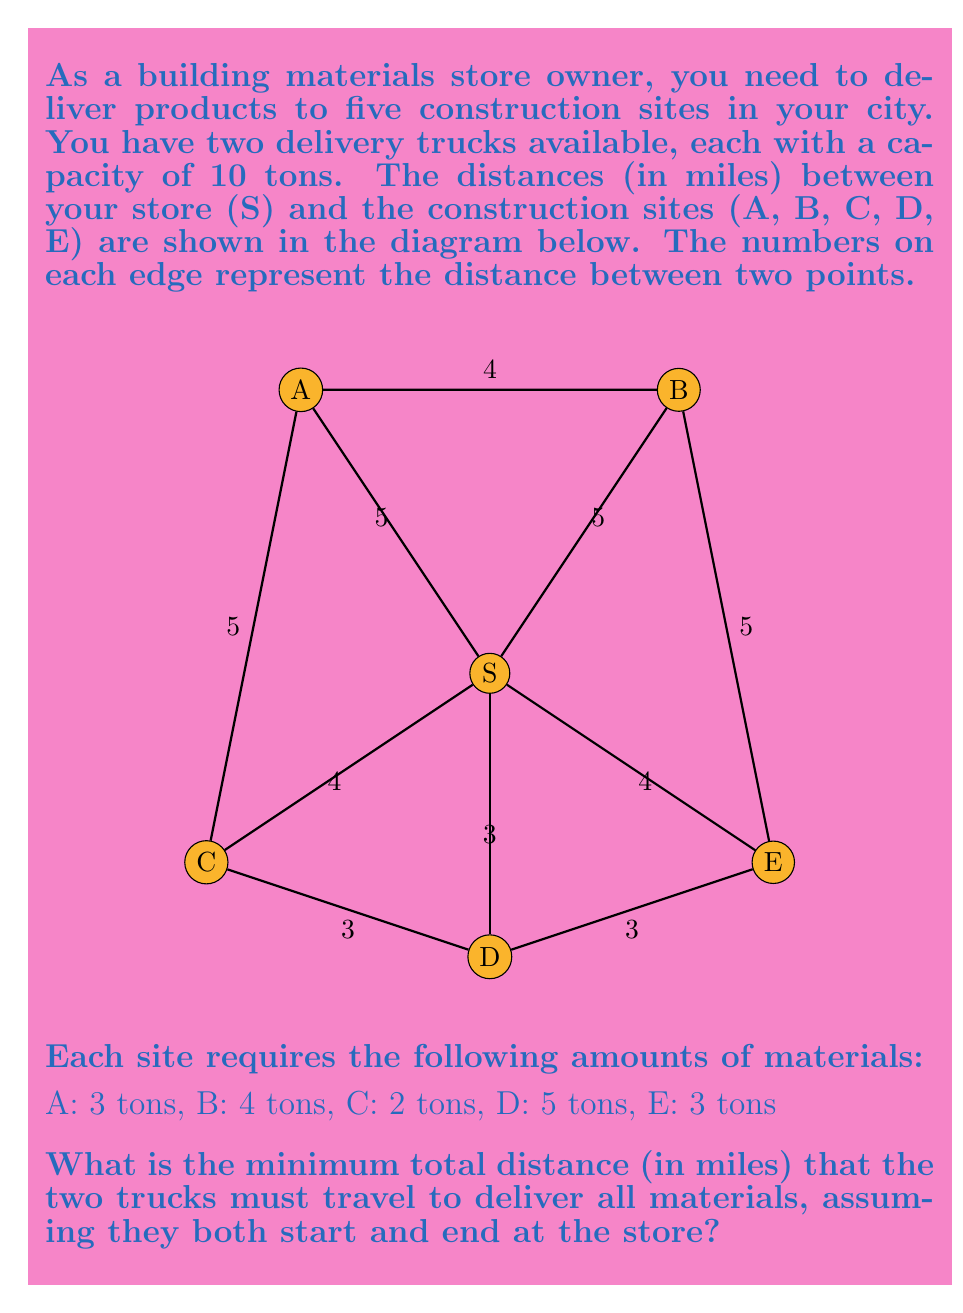Solve this math problem. To solve this problem, we'll use the following steps:

1) First, we need to determine how to distribute the deliveries between the two trucks. The total amount of materials to be delivered is:
   $3 + 4 + 2 + 5 + 3 = 17$ tons

2) Since each truck can carry 10 tons, we need to use both trucks. A possible efficient distribution could be:
   Truck 1: A (3 tons), B (4 tons), C (2 tons) = 9 tons
   Truck 2: D (5 tons), E (3 tons) = 8 tons

3) Now, we need to find the shortest route for each truck:

   For Truck 1:
   S → A → B → C → S
   Distance: $5 + 4 + 5 + 4 = 18$ miles

   For Truck 2:
   S → D → E → S
   Distance: $3 + 3 + 4 = 10$ miles

4) The total distance traveled by both trucks is:
   $18 + 10 = 28$ miles

Therefore, the minimum total distance that the two trucks must travel to deliver all materials is 28 miles.
Answer: 28 miles 